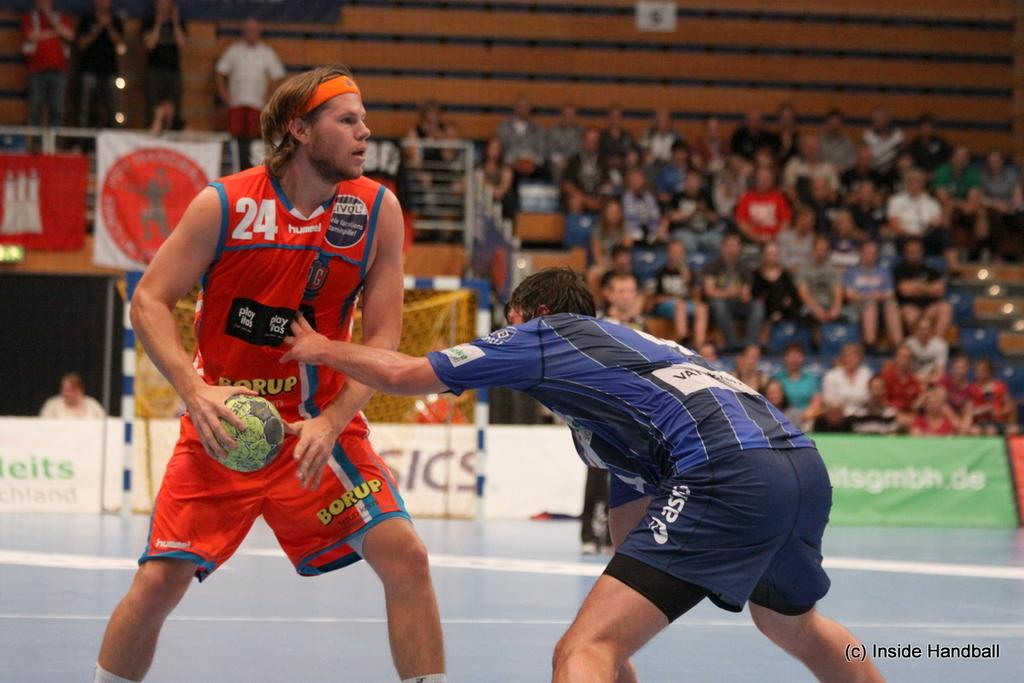<image>
Offer a succinct explanation of the picture presented. A photo of two players playing a game the corner says Inside Handball. 